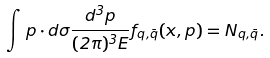<formula> <loc_0><loc_0><loc_500><loc_500>\int p \cdot d \sigma \frac { d ^ { 3 } { p } } { ( 2 \pi ) ^ { 3 } E } f _ { q , \bar { q } } ( x , p ) = N _ { q , \bar { q } } .</formula> 